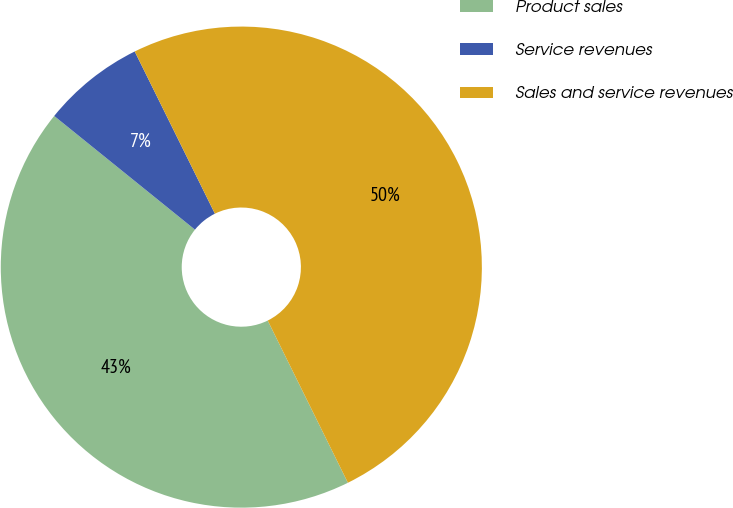<chart> <loc_0><loc_0><loc_500><loc_500><pie_chart><fcel>Product sales<fcel>Service revenues<fcel>Sales and service revenues<nl><fcel>43.12%<fcel>6.88%<fcel>50.0%<nl></chart> 